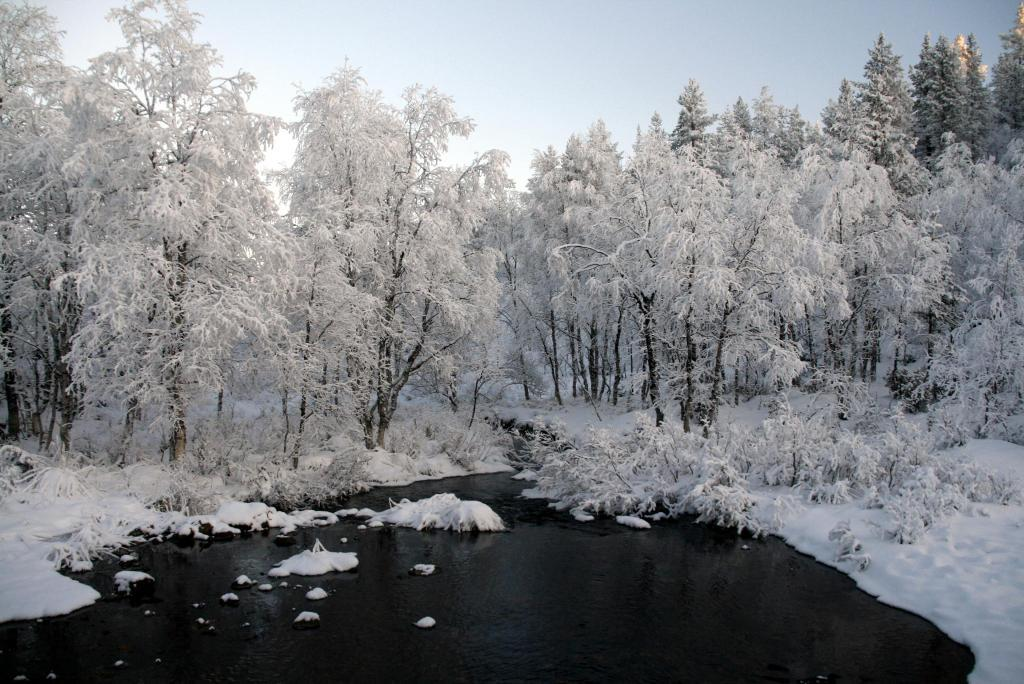What type of surface is visible in the image? There is a snow surface in the image. What else can be seen on the snow surface? There are trees on the snow surface. What is the color of the trees? The trees are white in color. What is visible in the background of the image? The sky is visible in the background of the image. What type of lawyer is present in the image? There is no lawyer present in the image. 